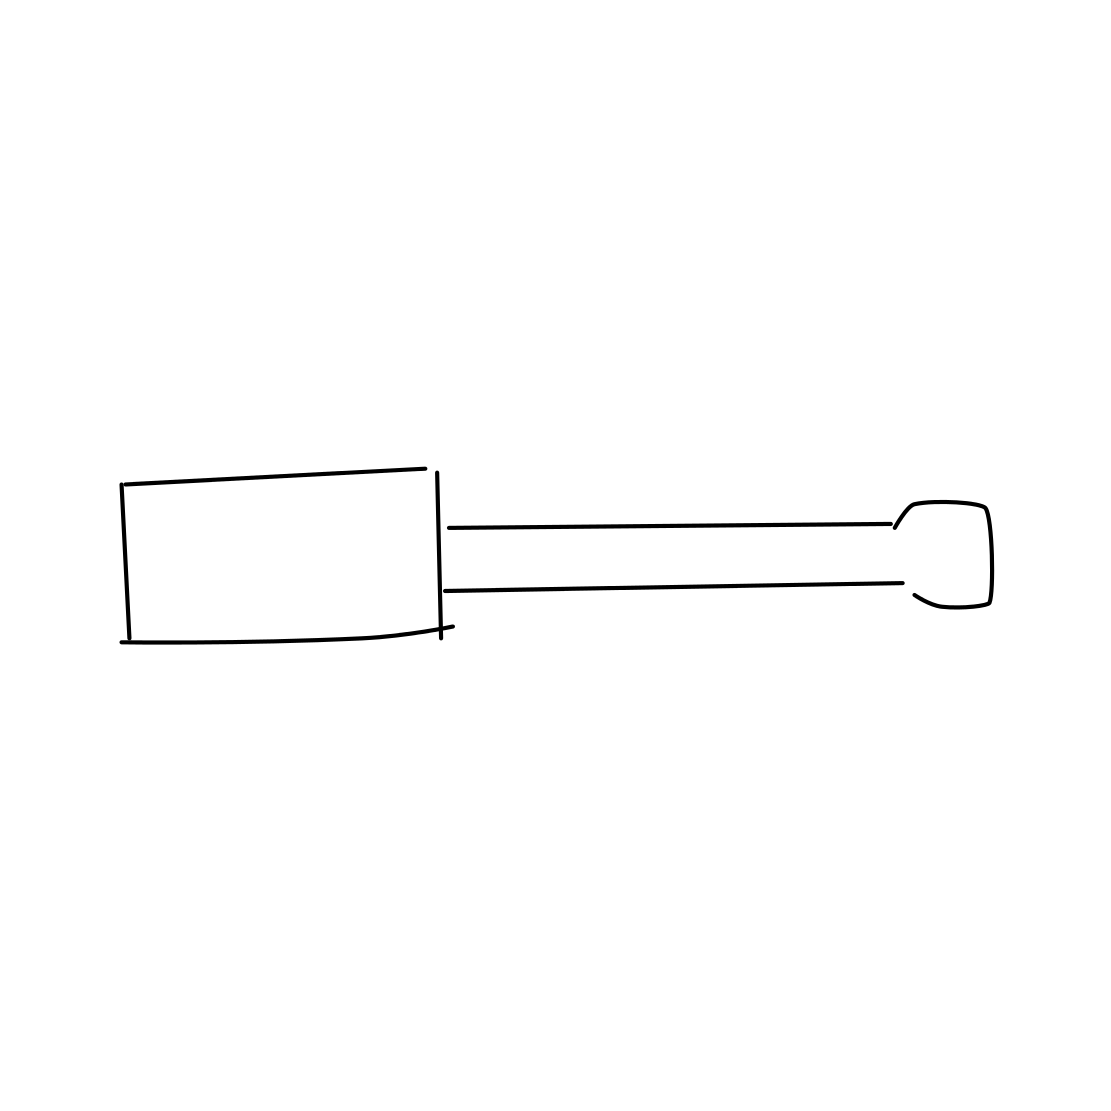Can you describe the handle of the screwdriver? The handle of the screwdriver appears to be quite wide relative to its length, suggesting it is designed for a comfortable grip to apply more torque comfortably when turning screws. 